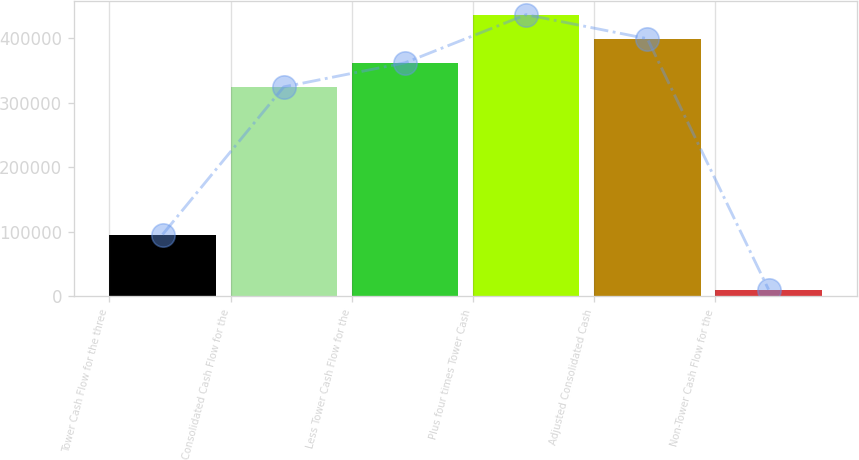<chart> <loc_0><loc_0><loc_500><loc_500><bar_chart><fcel>Tower Cash Flow for the three<fcel>Consolidated Cash Flow for the<fcel>Less Tower Cash Flow for the<fcel>Plus four times Tower Cash<fcel>Adjusted Consolidated Cash<fcel>Non-Tower Cash Flow for the<nl><fcel>95933<fcel>324676<fcel>361990<fcel>436618<fcel>399304<fcel>10591<nl></chart> 